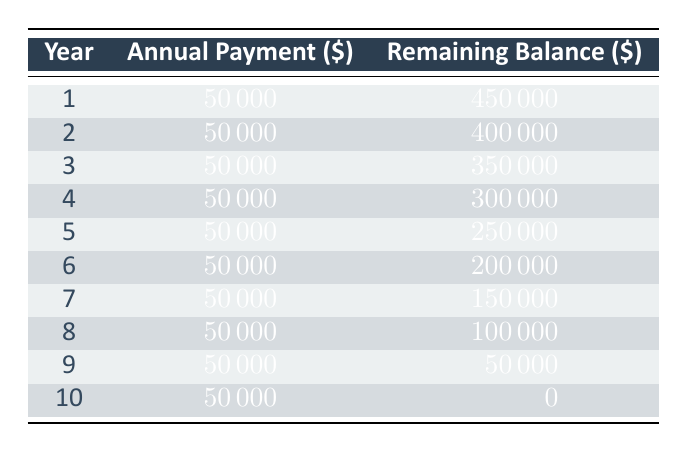What is the total investment made in carbon credits? The table states that the total investment is $500,000. This value is explicitly mentioned at the beginning of the data provided.
Answer: 500,000 How much is the annual payment for each year? The table shows that the annual payment remains consistent at $50,000 for all ten years. This is directly listed in each row of the "Annual Payment" column.
Answer: 50,000 What is the remaining balance after year 5? According to the table, after year 5, the remaining balance is $250,000, which is shown in the corresponding row for year 5.
Answer: 250,000 Is the remaining balance ever less than $100,000? Yes, the remaining balance becomes less than $100,000 after year 8, as indicated in the relevant rows of the table (specifically it is $100,000 after year 8 and $50,000 after year 9).
Answer: Yes What is the total amount paid after 10 years? To find the total amount paid, we sum the annual payments over 10 years: 10 years * $50,000 = $500,000. This calculation is based on the constant annual payment found in the table.
Answer: 500,000 What is the remaining balance at the end of year 3? The remaining balance at the end of year 3 as shown in the table is $350,000. This value can be directly found in the corresponding row for year 3.
Answer: 350,000 If no payments are made in year 7, what would the remaining balance be after year 7? If no payment is made in year 7, we would not subtract the $50,000 payment. Starting from the remaining balance after year 6 ($200,000), it remains the same at $200,000 at year 7. From there, after the usual payment in year 8, the balance would drop to $150,000, then to $100,000 in year 8’s normal payment. We find that at the end of year 7 it would still be $200,000.
Answer: 200,000 How much money is remaining after the last payment in year 10? After the last payment in year 10, the remaining balance is $0, as indicated in the table. This confirms that the entire investment has been amortized completely by that time.
Answer: 0 What is the average remaining balance over the 10 years? The remaining balances are: 450,000, 400,000, 350,000, 300,000, 250,000, 200,000, 150,000, 100,000, 50,000, and 0. The total sum of these balances is 0 + 50,000 + 100,000 + 150,000 + 200,000 + 250,000 + 300,000 + 350,000 + 400,000 + 450,000 = 2,500,000. Divided by 10 gives an average remaining balance of 250,000.
Answer: 250,000 